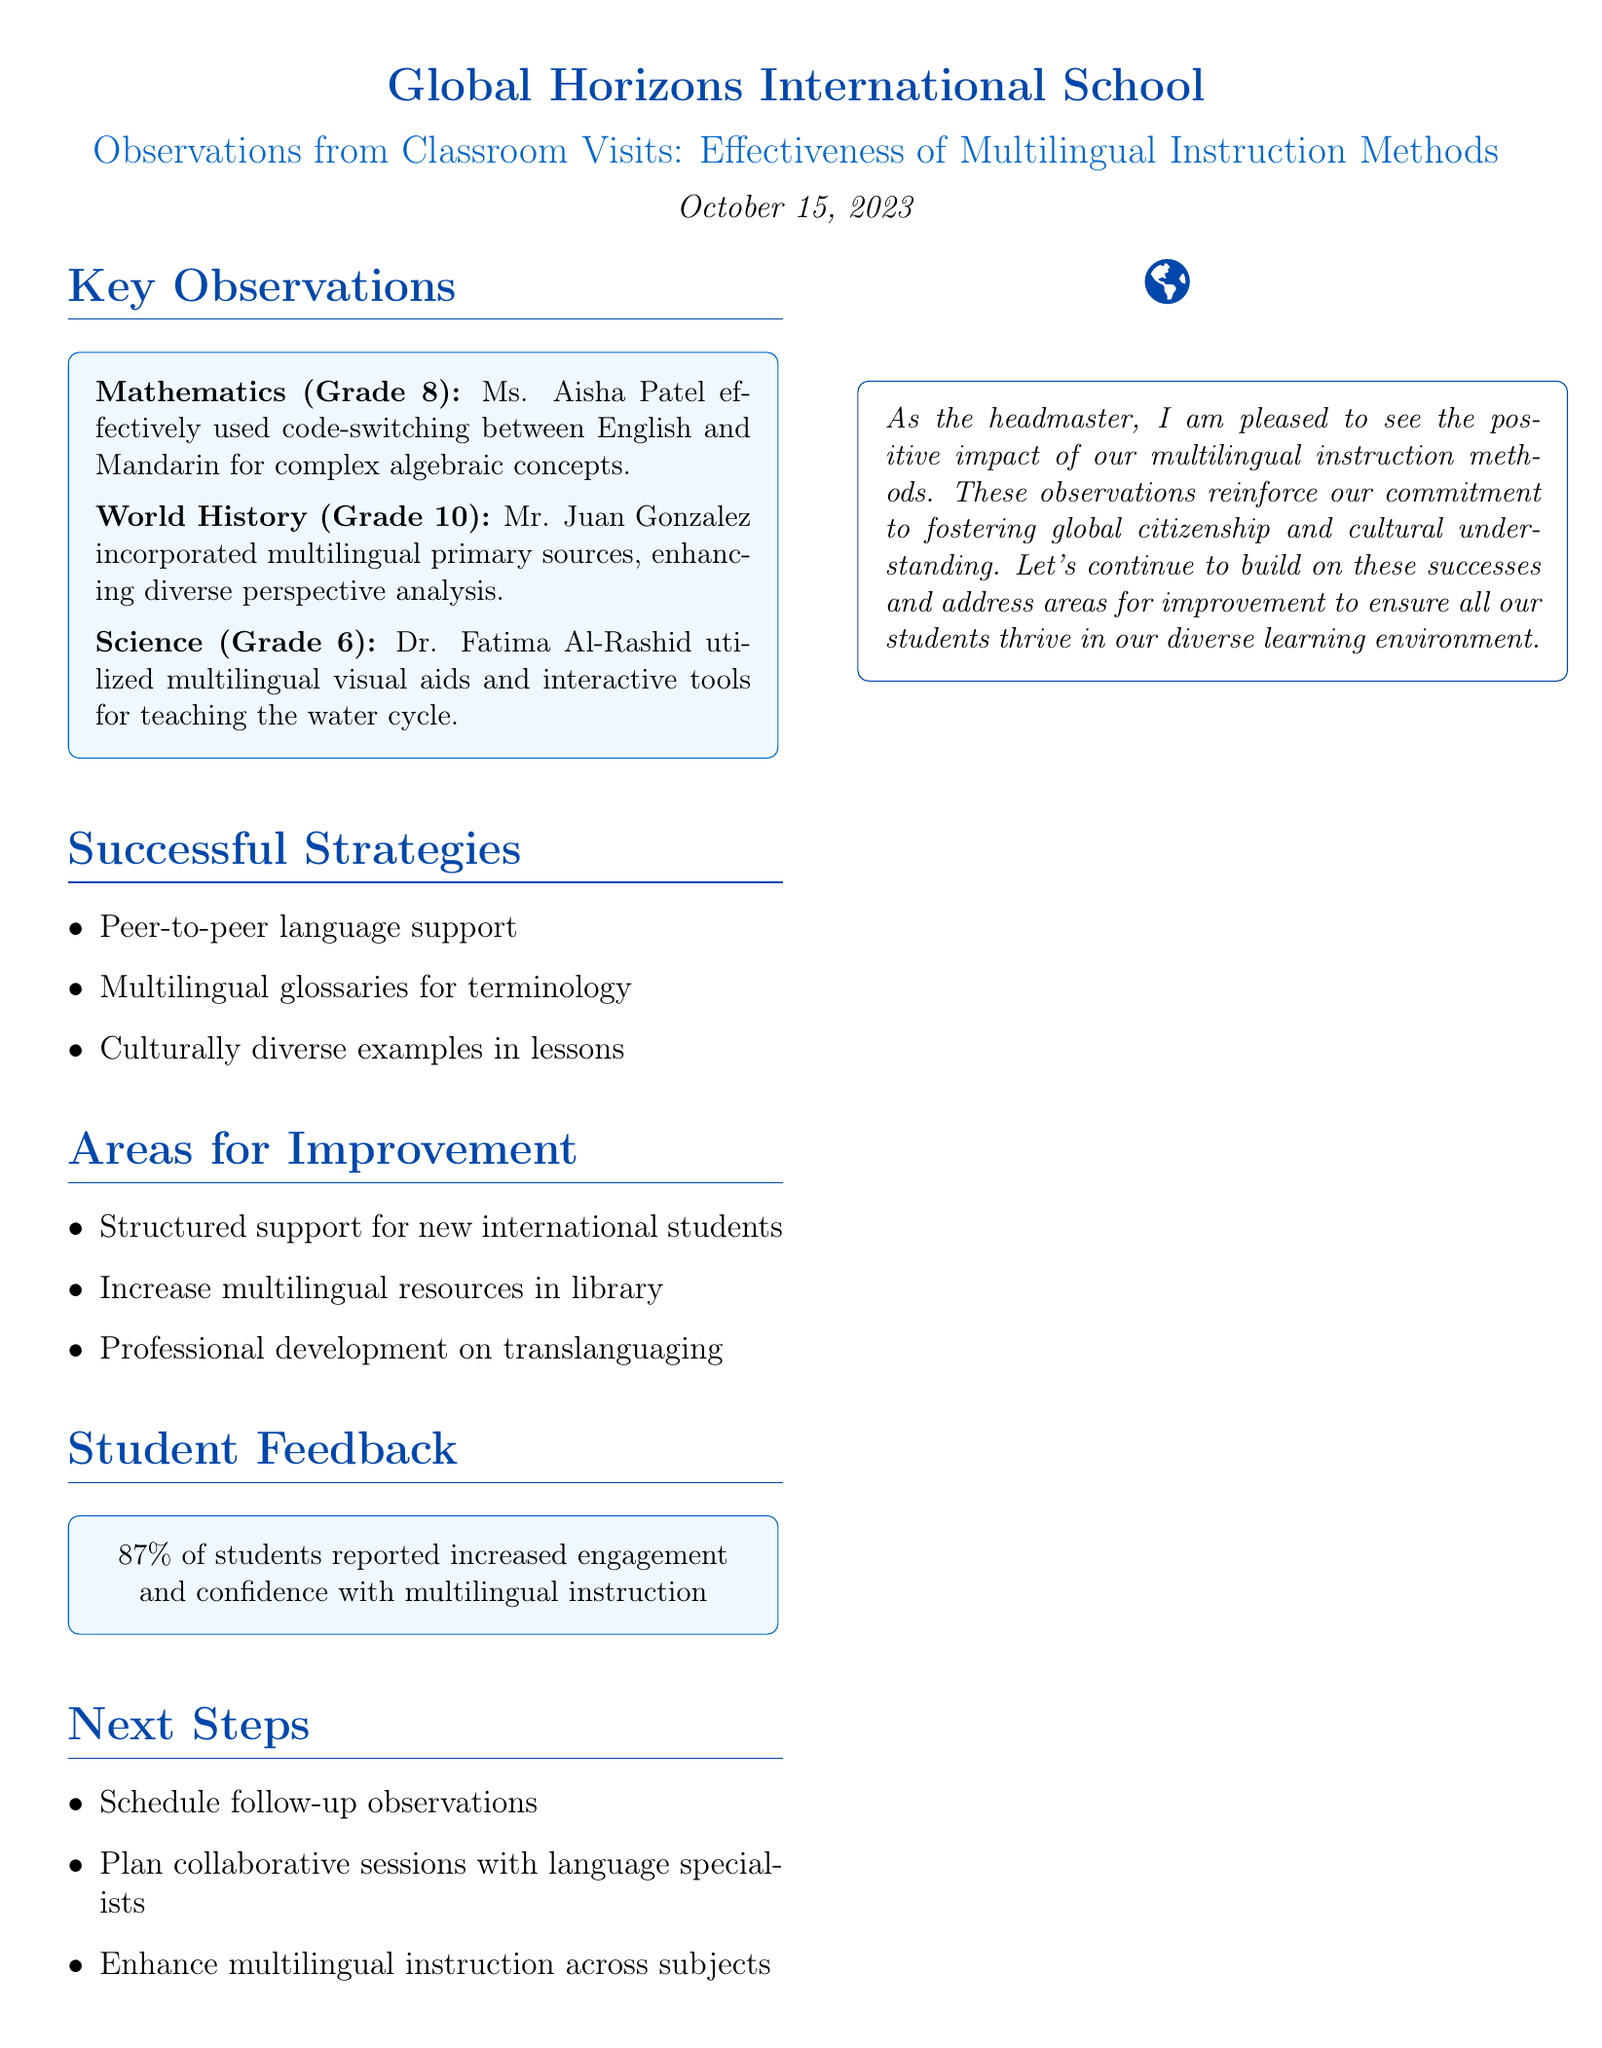What is the school name? The school name is mentioned in the document's title section.
Answer: Global Horizons International School What date were the observations made? The date of the observations is specified at the beginning of the document.
Answer: October 15, 2023 Who is the teacher for Grade 8 Mathematics? The teacher's name for Grade 8 Mathematics is provided in the key observations section.
Answer: Ms. Aisha Patel What percentage of students felt more engaged with multilingual instruction? The student feedback section includes a specific percentage on engagement levels.
Answer: 87% What subject did Mr. Juan Gonzalez teach? The subject taught by Mr. Juan Gonzalez is listed in the key observations section.
Answer: World History What is one area for improvement mentioned in the document? The areas for improvement section lists specific suggestions, and one of them can be selected.
Answer: Develop more structured language support for newly arrived international students Which teaching method was effectively used by Dr. Fatima Al-Rashid? The observation indicates the specific method used by Dr. Fatima in Science class.
Answer: Multilingual visual aids and interactive digital tools What is the next step identified for enhancing multilingual instruction? The next steps section outlines actions to be taken, and one of them can be highlighted as a response.
Answer: Schedule follow-up observations Which two languages were used in code-switching in the Math class? The specific languages used in code-switching are mentioned in the key observations for Mathematics.
Answer: English and Mandarin 